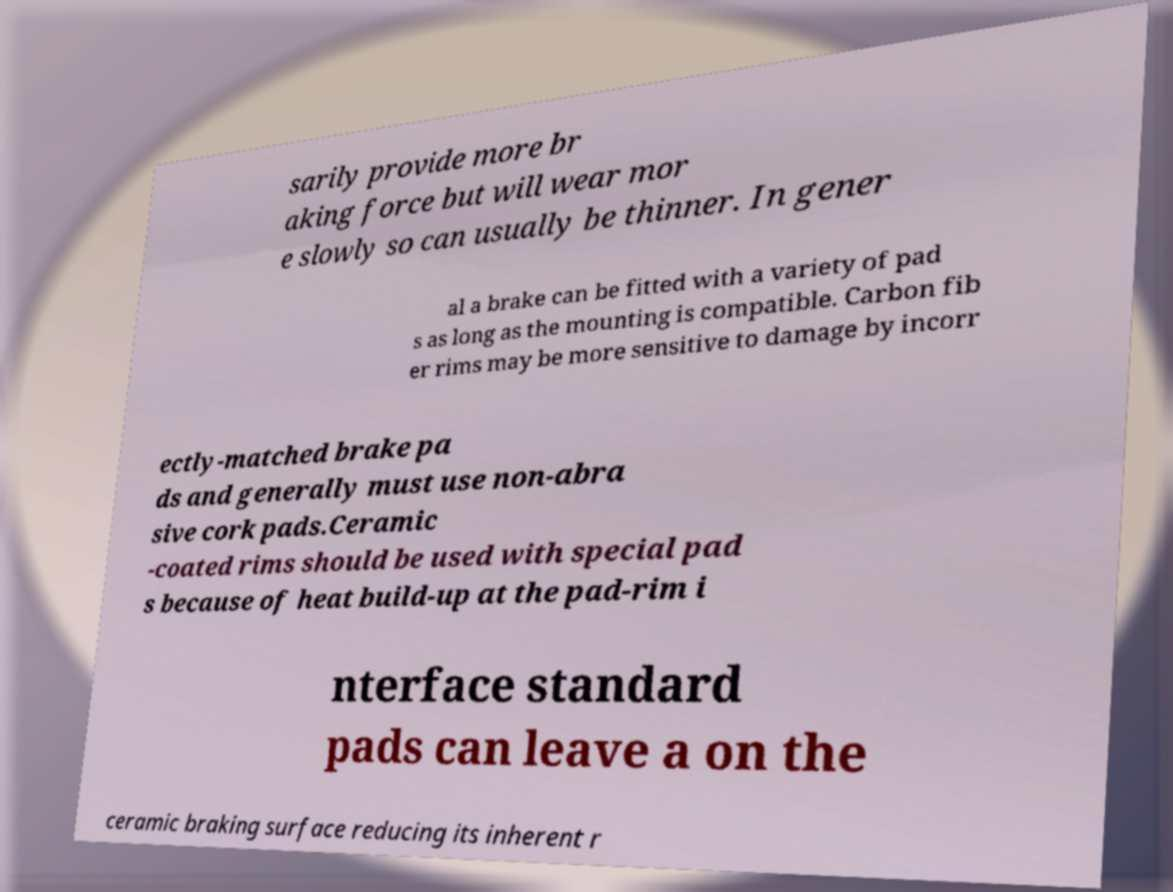Can you read and provide the text displayed in the image?This photo seems to have some interesting text. Can you extract and type it out for me? sarily provide more br aking force but will wear mor e slowly so can usually be thinner. In gener al a brake can be fitted with a variety of pad s as long as the mounting is compatible. Carbon fib er rims may be more sensitive to damage by incorr ectly-matched brake pa ds and generally must use non-abra sive cork pads.Ceramic -coated rims should be used with special pad s because of heat build-up at the pad-rim i nterface standard pads can leave a on the ceramic braking surface reducing its inherent r 